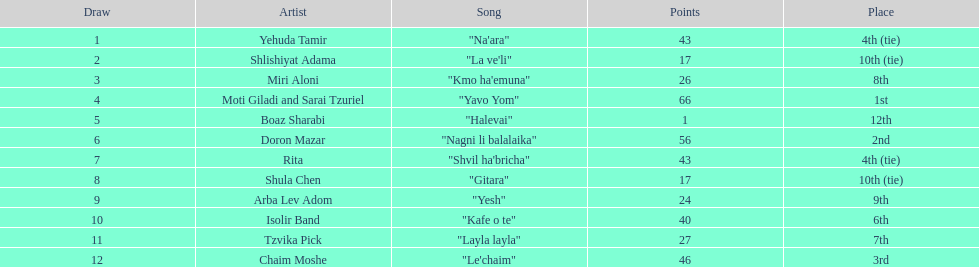Compare draws, which had the least amount of points? Boaz Sharabi. Could you help me parse every detail presented in this table? {'header': ['Draw', 'Artist', 'Song', 'Points', 'Place'], 'rows': [['1', 'Yehuda Tamir', '"Na\'ara"', '43', '4th (tie)'], ['2', 'Shlishiyat Adama', '"La ve\'li"', '17', '10th (tie)'], ['3', 'Miri Aloni', '"Kmo ha\'emuna"', '26', '8th'], ['4', 'Moti Giladi and Sarai Tzuriel', '"Yavo Yom"', '66', '1st'], ['5', 'Boaz Sharabi', '"Halevai"', '1', '12th'], ['6', 'Doron Mazar', '"Nagni li balalaika"', '56', '2nd'], ['7', 'Rita', '"Shvil ha\'bricha"', '43', '4th (tie)'], ['8', 'Shula Chen', '"Gitara"', '17', '10th (tie)'], ['9', 'Arba Lev Adom', '"Yesh"', '24', '9th'], ['10', 'Isolir Band', '"Kafe o te"', '40', '6th'], ['11', 'Tzvika Pick', '"Layla layla"', '27', '7th'], ['12', 'Chaim Moshe', '"Le\'chaim"', '46', '3rd']]} 